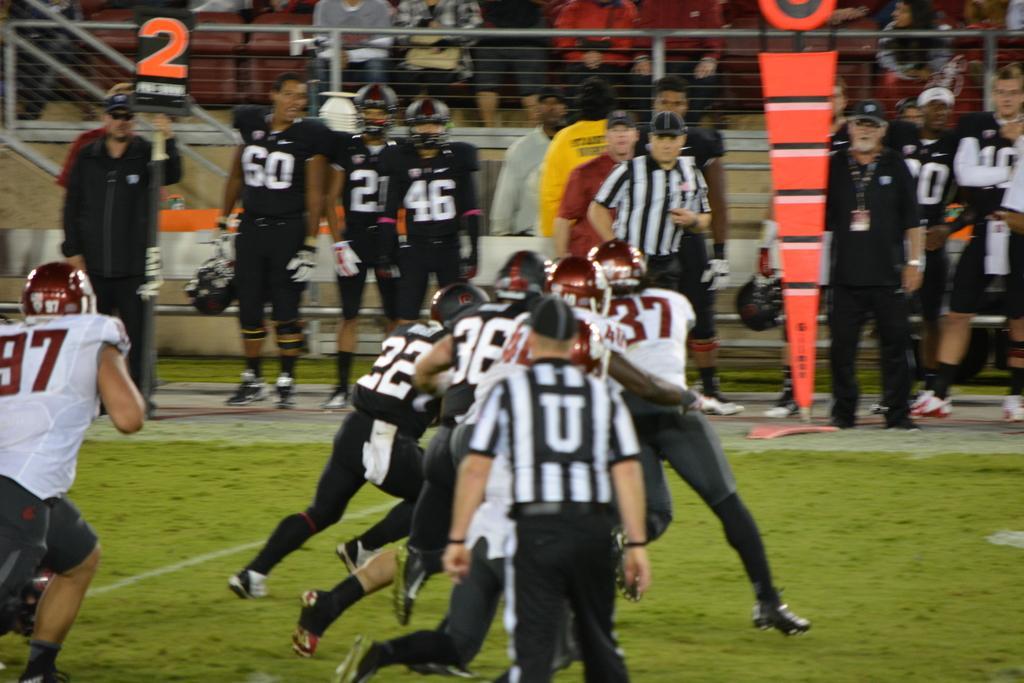Please provide a concise description of this image. In this image in the foreground there are some people who are playing something, and in the background there are some people who are standing and watching the game and some of them are sitting on chairs. And we could see a wall, net and some boards. At the bottom there is grass. 